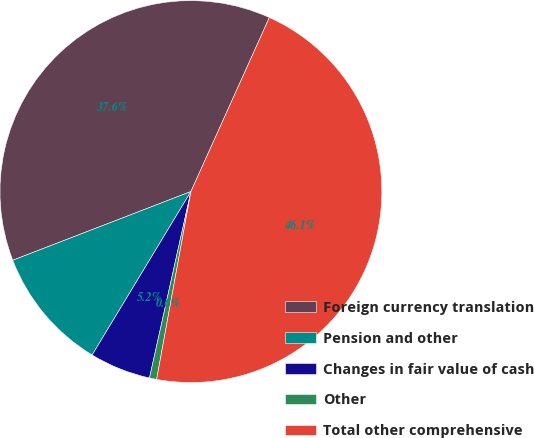<chart> <loc_0><loc_0><loc_500><loc_500><pie_chart><fcel>Foreign currency translation<fcel>Pension and other<fcel>Changes in fair value of cash<fcel>Other<fcel>Total other comprehensive<nl><fcel>37.6%<fcel>10.49%<fcel>5.17%<fcel>0.61%<fcel>46.13%<nl></chart> 